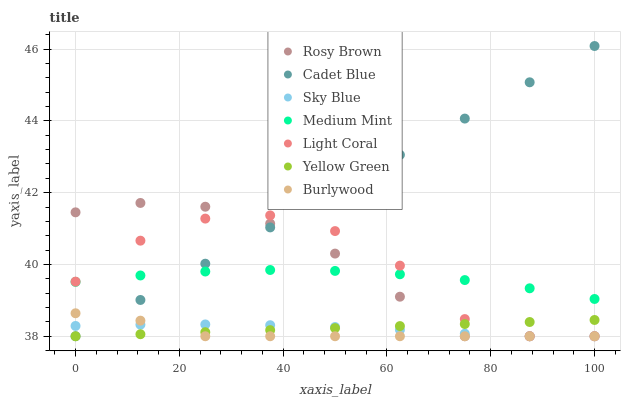Does Burlywood have the minimum area under the curve?
Answer yes or no. Yes. Does Cadet Blue have the maximum area under the curve?
Answer yes or no. Yes. Does Yellow Green have the minimum area under the curve?
Answer yes or no. No. Does Yellow Green have the maximum area under the curve?
Answer yes or no. No. Is Cadet Blue the smoothest?
Answer yes or no. Yes. Is Light Coral the roughest?
Answer yes or no. Yes. Is Yellow Green the smoothest?
Answer yes or no. No. Is Yellow Green the roughest?
Answer yes or no. No. Does Cadet Blue have the lowest value?
Answer yes or no. Yes. Does Cadet Blue have the highest value?
Answer yes or no. Yes. Does Yellow Green have the highest value?
Answer yes or no. No. Is Yellow Green less than Medium Mint?
Answer yes or no. Yes. Is Medium Mint greater than Yellow Green?
Answer yes or no. Yes. Does Yellow Green intersect Sky Blue?
Answer yes or no. Yes. Is Yellow Green less than Sky Blue?
Answer yes or no. No. Is Yellow Green greater than Sky Blue?
Answer yes or no. No. Does Yellow Green intersect Medium Mint?
Answer yes or no. No. 